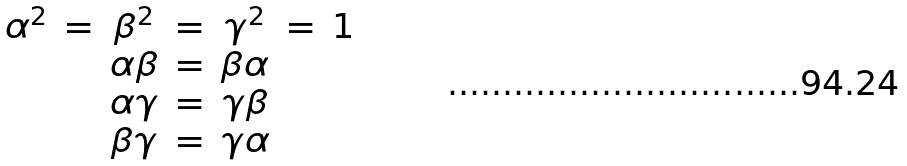<formula> <loc_0><loc_0><loc_500><loc_500>\begin{array} { c c c c c c c } \alpha ^ { 2 } & = & \beta ^ { 2 } & = & \gamma ^ { 2 } & = & 1 \\ & & \alpha \beta & = & \beta \alpha & & \\ & & \alpha \gamma & = & \gamma \beta & & \\ & & \beta \gamma & = & \gamma \alpha & & \end{array}</formula> 